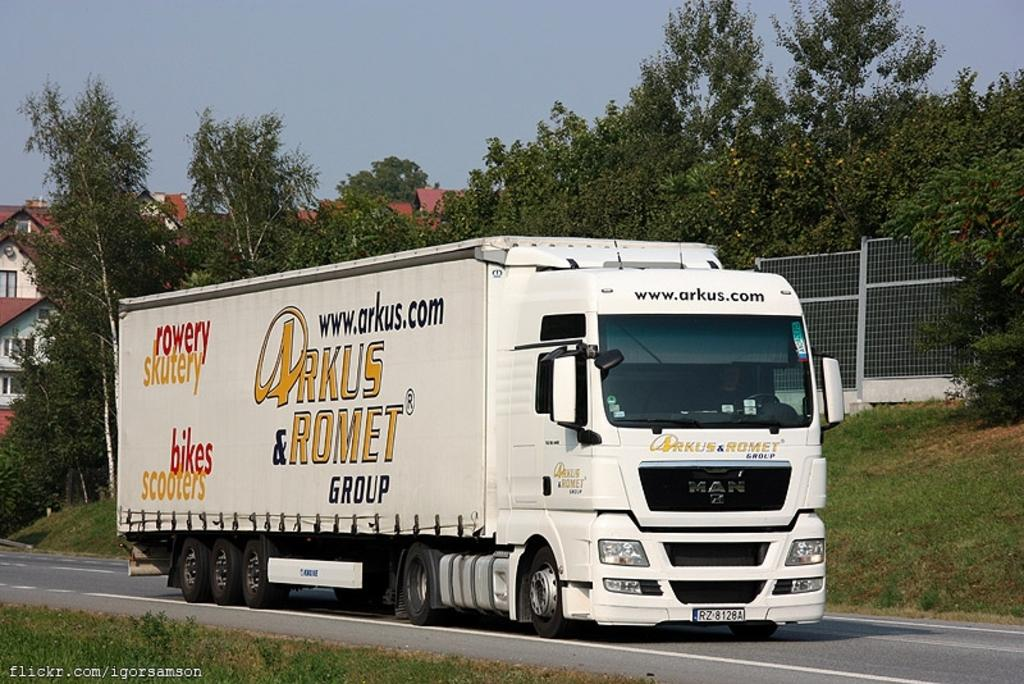What type of vehicle is on the road in the image? There is a truck on the road in the image. What is located behind the truck? There is a fence behind the truck. What type of vegetation can be seen in the image? There are trees visible in the image. What type of structures are in the background of the image? There are houses in the background of the image. What part of the natural environment is visible in the image? The sky is visible in the image. What type of fowl can be seen walking around the truck in the image? There are no fowl present in the image; it only features a truck, a fence, trees, houses, and the sky. How does the truck look in the image? The truck's appearance cannot be described as a look; it is a physical object in the image. 